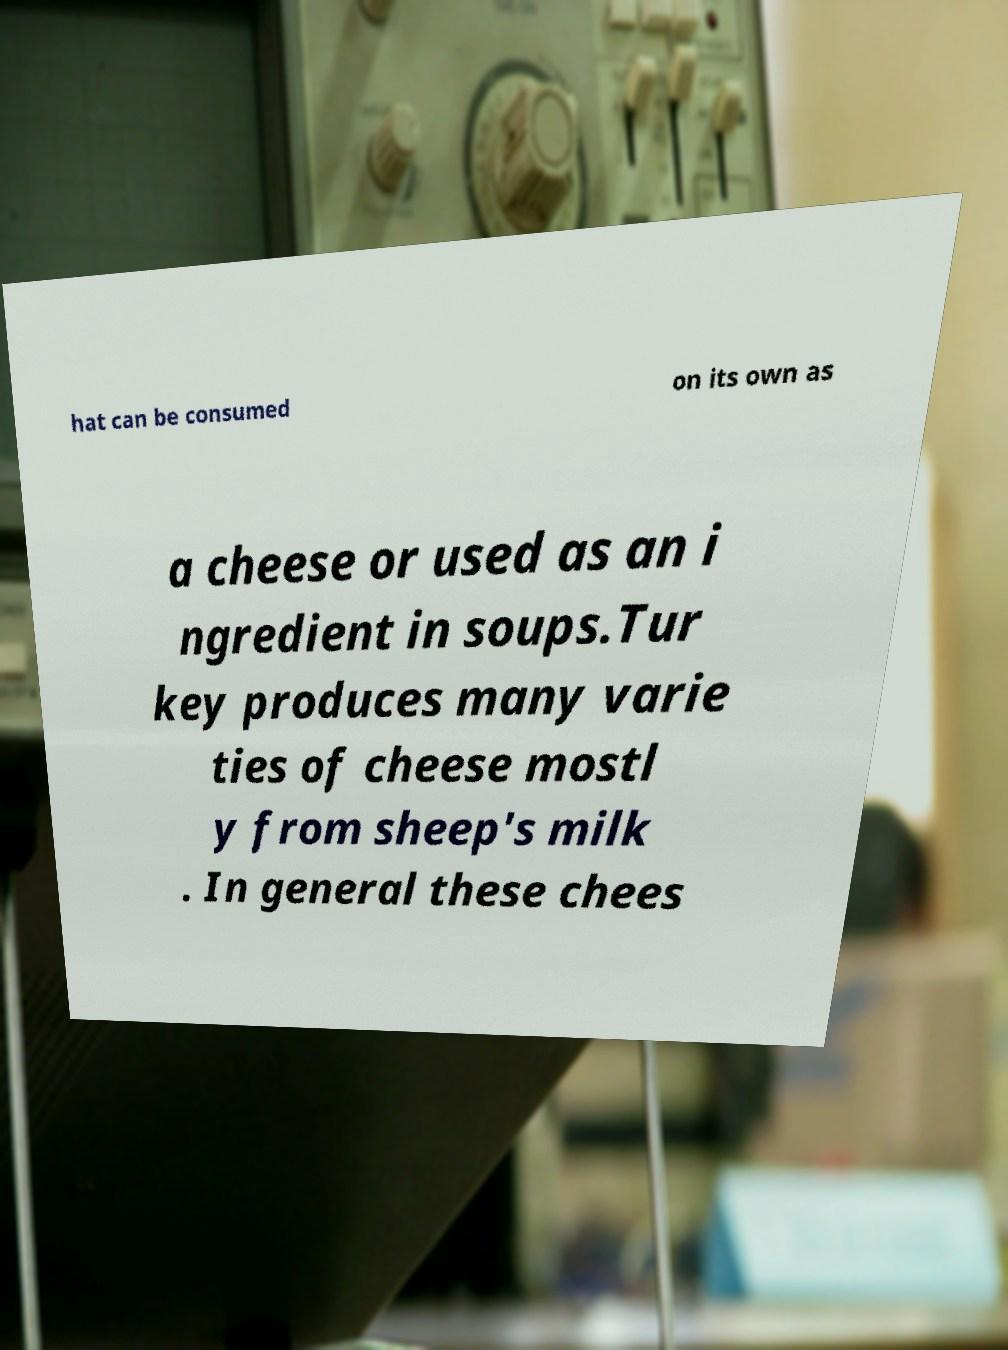Can you accurately transcribe the text from the provided image for me? hat can be consumed on its own as a cheese or used as an i ngredient in soups.Tur key produces many varie ties of cheese mostl y from sheep's milk . In general these chees 